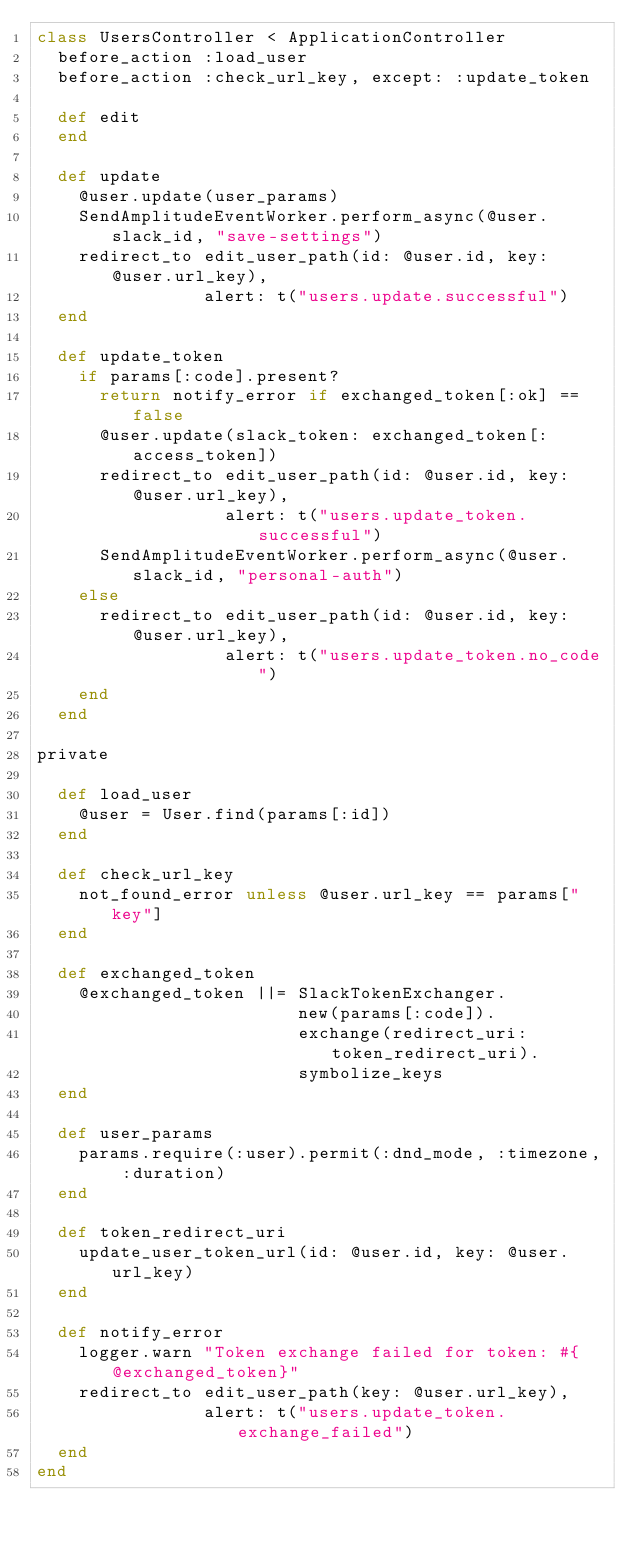Convert code to text. <code><loc_0><loc_0><loc_500><loc_500><_Ruby_>class UsersController < ApplicationController
  before_action :load_user
  before_action :check_url_key, except: :update_token

  def edit 
  end

  def update
    @user.update(user_params)
    SendAmplitudeEventWorker.perform_async(@user.slack_id, "save-settings")
    redirect_to edit_user_path(id: @user.id, key: @user.url_key), 
                alert: t("users.update.successful")
  end

  def update_token
    if params[:code].present?
      return notify_error if exchanged_token[:ok] == false
      @user.update(slack_token: exchanged_token[:access_token])
      redirect_to edit_user_path(id: @user.id, key: @user.url_key), 
                  alert: t("users.update_token.successful")
      SendAmplitudeEventWorker.perform_async(@user.slack_id, "personal-auth")
    else
      redirect_to edit_user_path(id: @user.id, key: @user.url_key), 
                  alert: t("users.update_token.no_code")
    end
  end

private

  def load_user
    @user = User.find(params[:id])
  end

  def check_url_key
    not_found_error unless @user.url_key == params["key"]
  end

  def exchanged_token
    @exchanged_token ||= SlackTokenExchanger.
                         new(params[:code]).
                         exchange(redirect_uri: token_redirect_uri).
                         symbolize_keys
  end

  def user_params
    params.require(:user).permit(:dnd_mode, :timezone, :duration)
  end

  def token_redirect_uri
    update_user_token_url(id: @user.id, key: @user.url_key)
  end

  def notify_error
    logger.warn "Token exchange failed for token: #{@exchanged_token}"
    redirect_to edit_user_path(key: @user.url_key), 
                alert: t("users.update_token.exchange_failed")
  end
end
</code> 